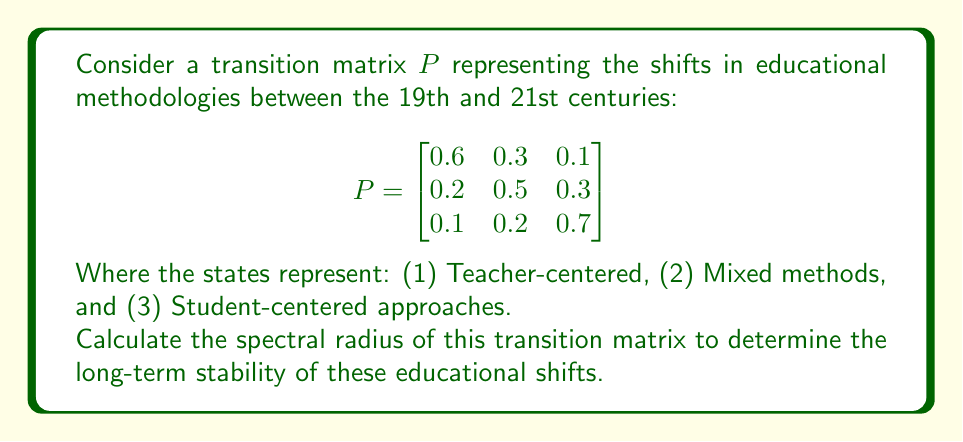Show me your answer to this math problem. To calculate the spectral radius of the transition matrix $P$, we need to follow these steps:

1) Find the characteristic equation:
   $\det(P - \lambda I) = 0$

   $$\begin{vmatrix}
   0.6 - \lambda & 0.3 & 0.1 \\
   0.2 & 0.5 - \lambda & 0.3 \\
   0.1 & 0.2 & 0.7 - \lambda
   \end{vmatrix} = 0$$

2) Expand the determinant:
   $(0.6 - \lambda)[(0.5 - \lambda)(0.7 - \lambda) - 0.06] - 0.3[0.2(0.7 - \lambda) - 0.03] + 0.1[0.2(0.5 - \lambda) - 0.06] = 0$

3) Simplify:
   $-\lambda^3 + 1.8\lambda^2 - 0.98\lambda + 0.162 = 0$

4) Solve this cubic equation. The roots are the eigenvalues of $P$. Using a numerical method or a calculator, we find:
   $\lambda_1 \approx 1$
   $\lambda_2 \approx 0.5$
   $\lambda_3 \approx 0.3$

5) The spectral radius is the largest absolute value among these eigenvalues:
   $\rho(P) = \max(|\lambda_1|, |\lambda_2|, |\lambda_3|) = \max(1, 0.5, 0.3) = 1$

The spectral radius being 1 indicates that the Markov chain is regular and will converge to a stable distribution in the long term.
Answer: $\rho(P) = 1$ 